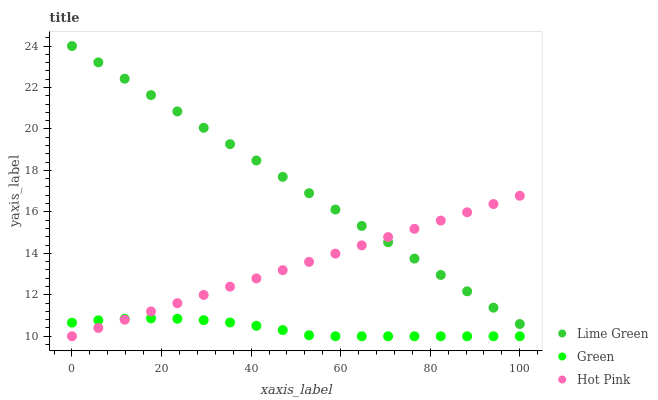Does Green have the minimum area under the curve?
Answer yes or no. Yes. Does Lime Green have the maximum area under the curve?
Answer yes or no. Yes. Does Hot Pink have the minimum area under the curve?
Answer yes or no. No. Does Hot Pink have the maximum area under the curve?
Answer yes or no. No. Is Lime Green the smoothest?
Answer yes or no. Yes. Is Green the roughest?
Answer yes or no. Yes. Is Hot Pink the smoothest?
Answer yes or no. No. Is Hot Pink the roughest?
Answer yes or no. No. Does Green have the lowest value?
Answer yes or no. Yes. Does Lime Green have the lowest value?
Answer yes or no. No. Does Lime Green have the highest value?
Answer yes or no. Yes. Does Hot Pink have the highest value?
Answer yes or no. No. Is Green less than Lime Green?
Answer yes or no. Yes. Is Lime Green greater than Green?
Answer yes or no. Yes. Does Hot Pink intersect Lime Green?
Answer yes or no. Yes. Is Hot Pink less than Lime Green?
Answer yes or no. No. Is Hot Pink greater than Lime Green?
Answer yes or no. No. Does Green intersect Lime Green?
Answer yes or no. No. 